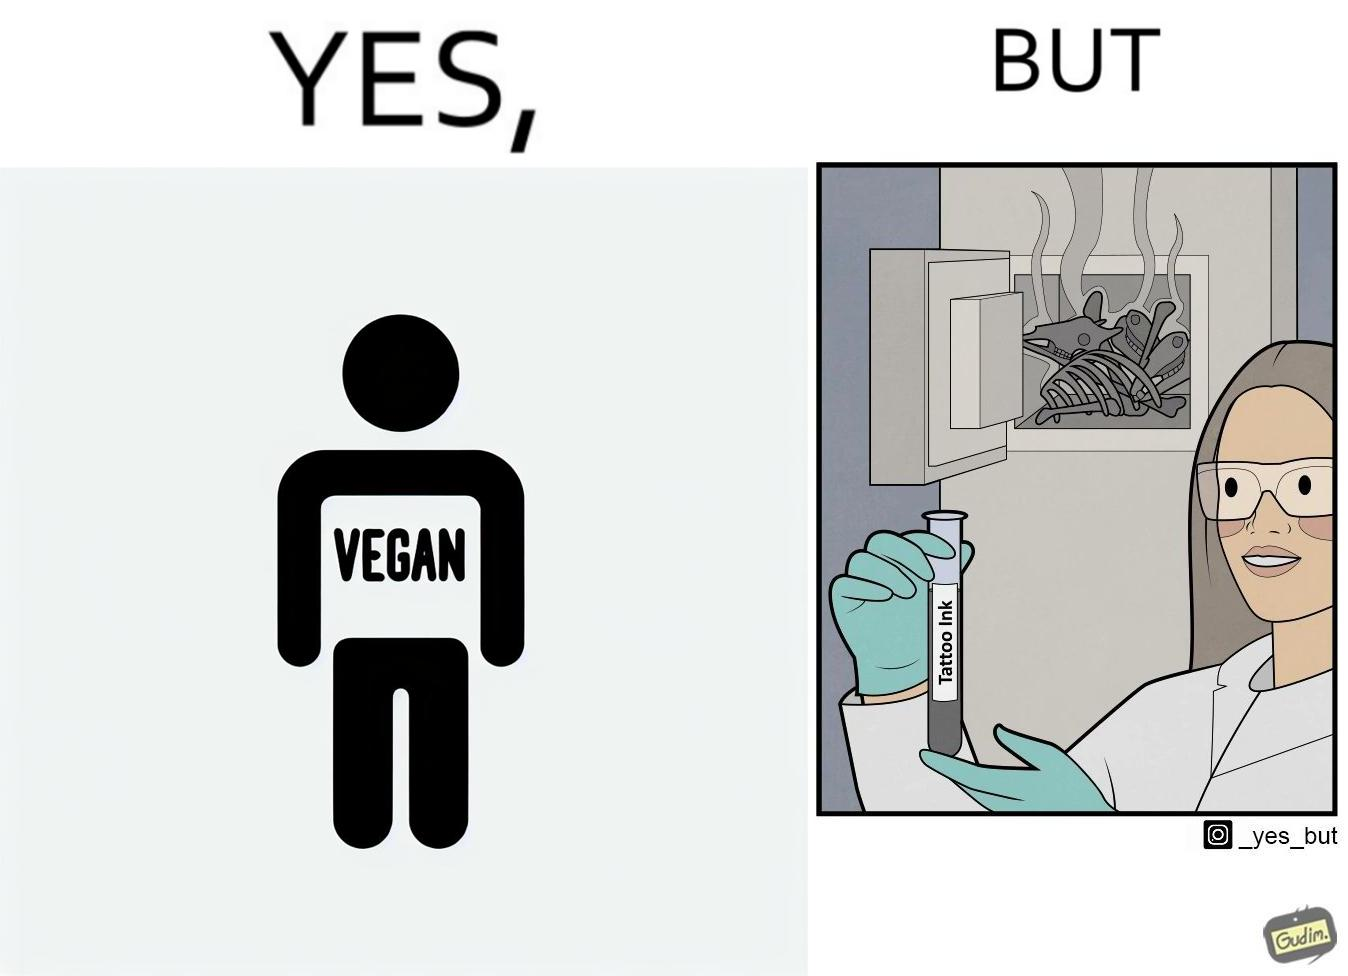What is the satirical meaning behind this image? The irony in this video is that people try to promote and embrace veganism end up using products that are not animal-free. 